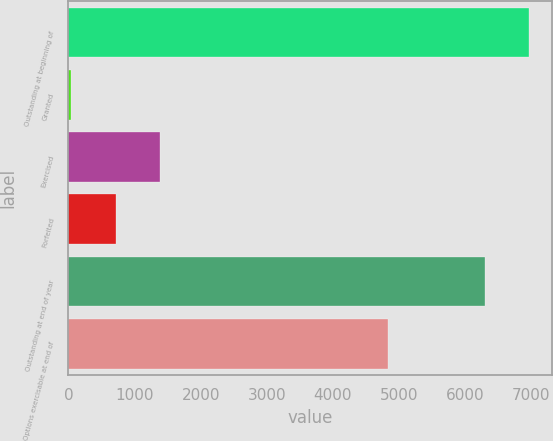Convert chart to OTSL. <chart><loc_0><loc_0><loc_500><loc_500><bar_chart><fcel>Outstanding at beginning of<fcel>Granted<fcel>Exercised<fcel>Forfeited<fcel>Outstanding at end of year<fcel>Options exercisable at end of<nl><fcel>6970<fcel>42<fcel>1392<fcel>717<fcel>6295<fcel>4835<nl></chart> 